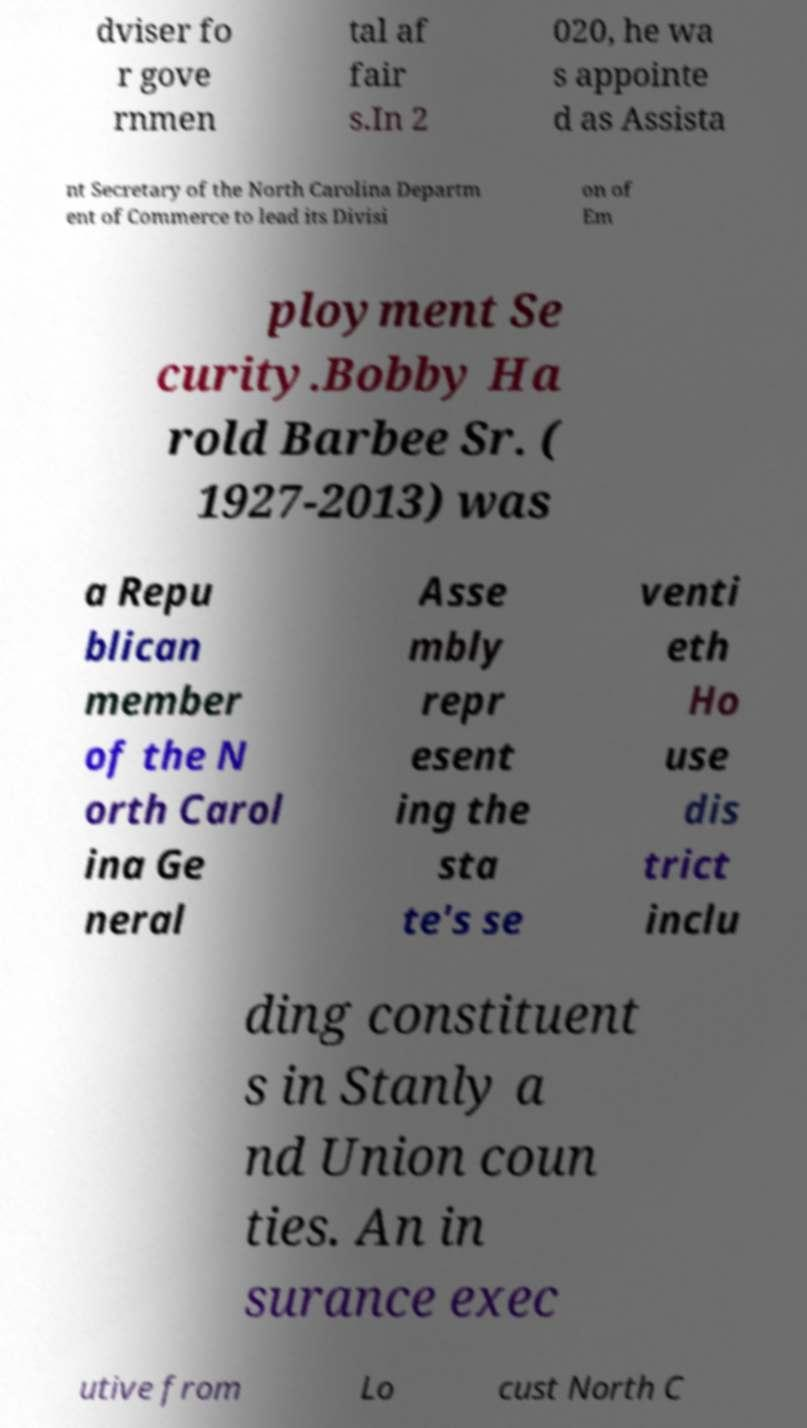Can you read and provide the text displayed in the image?This photo seems to have some interesting text. Can you extract and type it out for me? dviser fo r gove rnmen tal af fair s.In 2 020, he wa s appointe d as Assista nt Secretary of the North Carolina Departm ent of Commerce to lead its Divisi on of Em ployment Se curity.Bobby Ha rold Barbee Sr. ( 1927-2013) was a Repu blican member of the N orth Carol ina Ge neral Asse mbly repr esent ing the sta te's se venti eth Ho use dis trict inclu ding constituent s in Stanly a nd Union coun ties. An in surance exec utive from Lo cust North C 